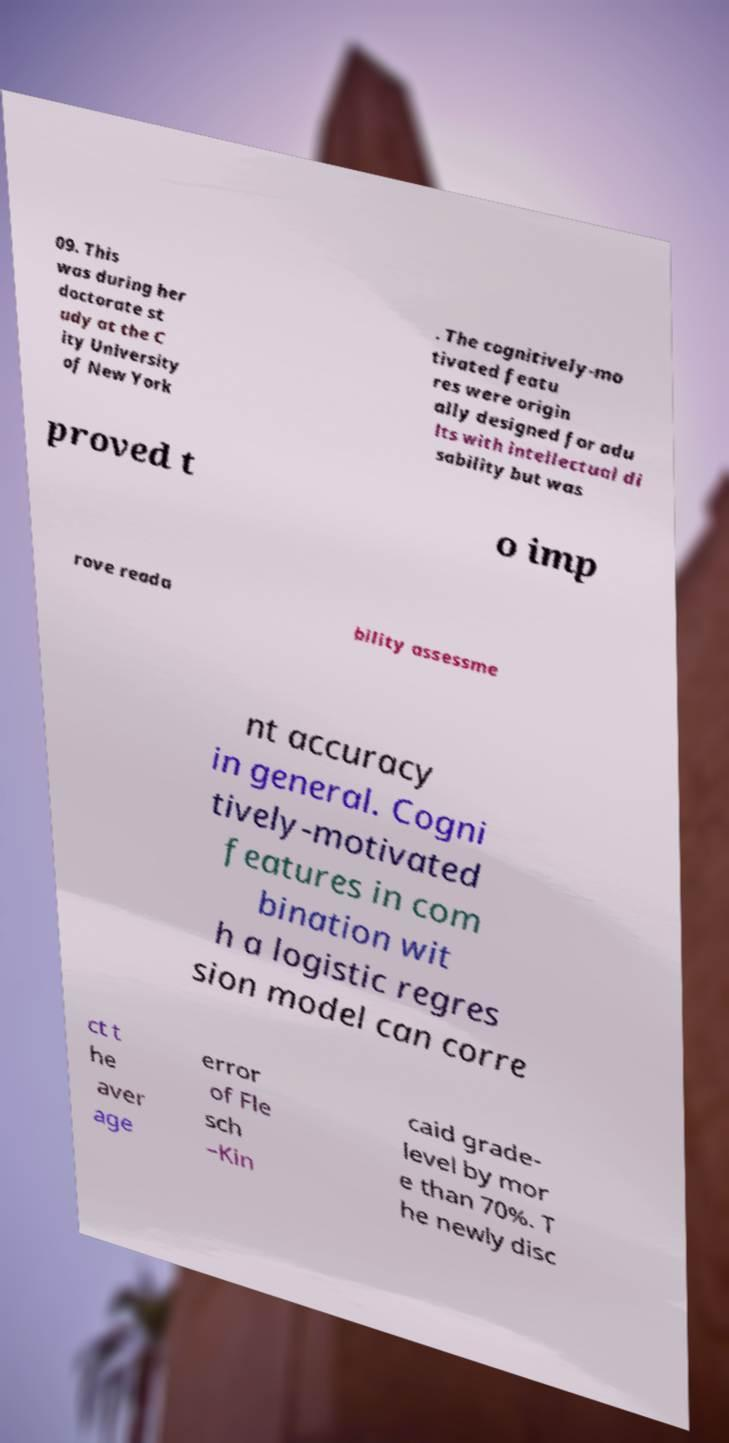For documentation purposes, I need the text within this image transcribed. Could you provide that? 09. This was during her doctorate st udy at the C ity University of New York . The cognitively-mo tivated featu res were origin ally designed for adu lts with intellectual di sability but was proved t o imp rove reada bility assessme nt accuracy in general. Cogni tively-motivated features in com bination wit h a logistic regres sion model can corre ct t he aver age error of Fle sch –Kin caid grade- level by mor e than 70%. T he newly disc 